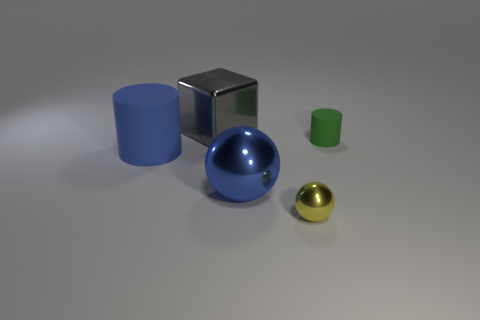There is a tiny object that is behind the large blue thing on the right side of the large object behind the blue cylinder; what color is it? green 